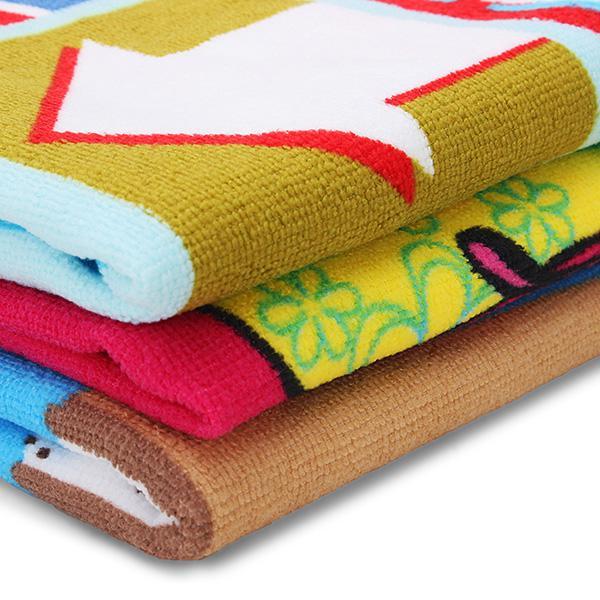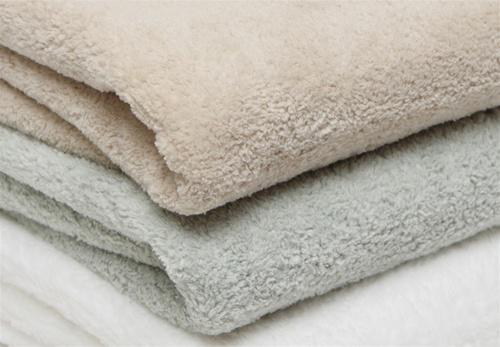The first image is the image on the left, the second image is the image on the right. For the images displayed, is the sentence "One image features exactly five folded towels in primarily blue and brown shades." factually correct? Answer yes or no. No. The first image is the image on the left, the second image is the image on the right. Considering the images on both sides, is "In one image, exactly five different colored towels, which are folded with edges to the inside, have been placed in a stack." valid? Answer yes or no. No. 